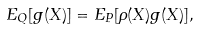<formula> <loc_0><loc_0><loc_500><loc_500>E _ { Q } [ g ( X ) ] = E _ { P } [ \rho ( X ) g ( X ) ] ,</formula> 